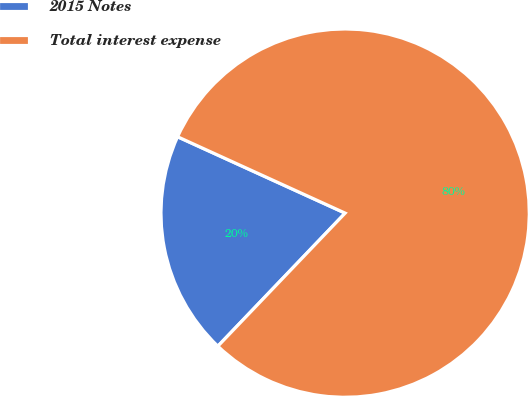<chart> <loc_0><loc_0><loc_500><loc_500><pie_chart><fcel>2015 Notes<fcel>Total interest expense<nl><fcel>19.66%<fcel>80.34%<nl></chart> 